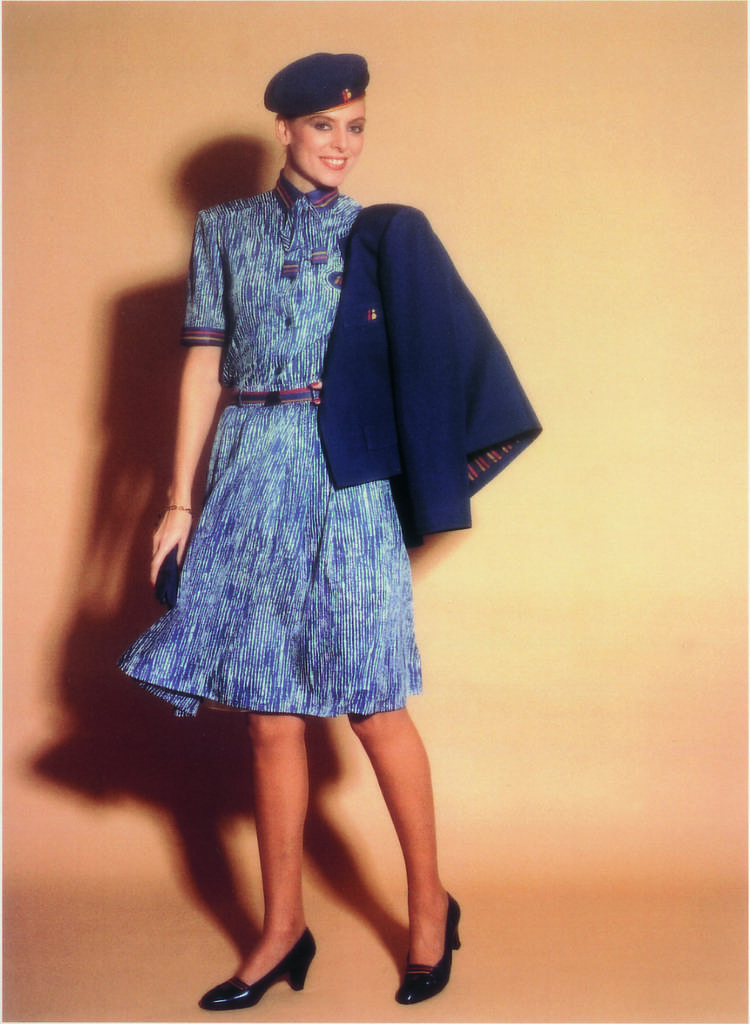How would you summarize this image in a sentence or two? In this image, we can see a woman holding an object and standing on the floor. She is smiling and wearing a cap. In the background, we can see a shadow on the wall. 